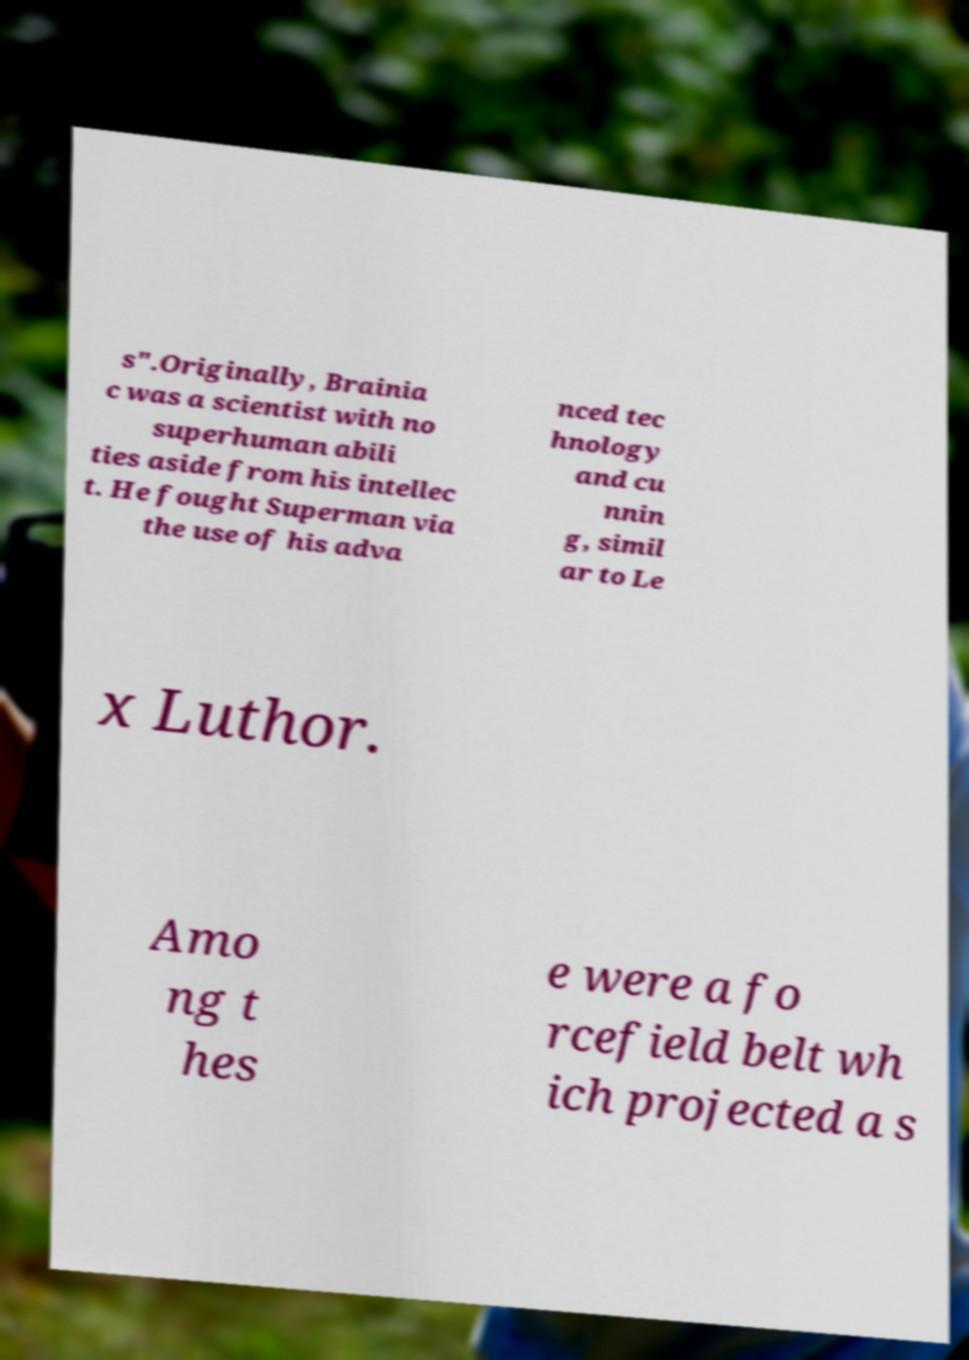Can you accurately transcribe the text from the provided image for me? s".Originally, Brainia c was a scientist with no superhuman abili ties aside from his intellec t. He fought Superman via the use of his adva nced tec hnology and cu nnin g, simil ar to Le x Luthor. Amo ng t hes e were a fo rcefield belt wh ich projected a s 